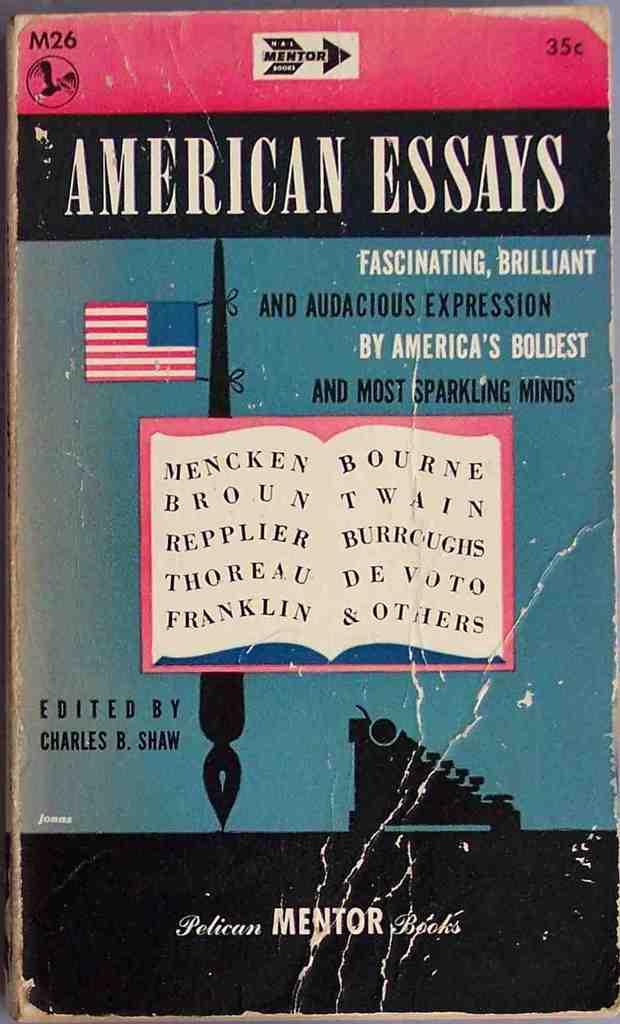<image>
Create a compact narrative representing the image presented. A battered book with American Essays written on the front. 